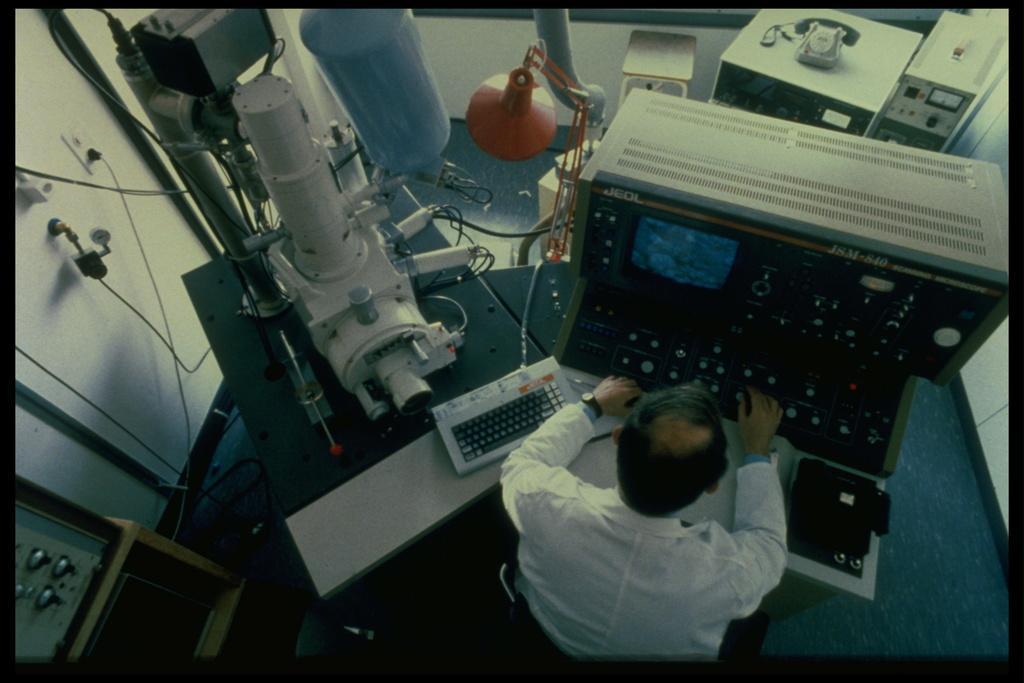Can you describe this image briefly? This picture shows a man seated on the chair and and we see a monitor and a keyboard on the table and we see a telephone and a stand light and few machines and we see a man operating the machine. 